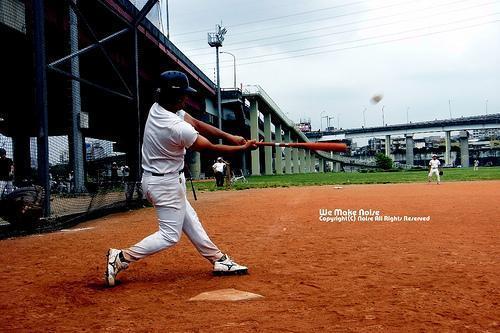How many red umbrellas are there?
Give a very brief answer. 0. 